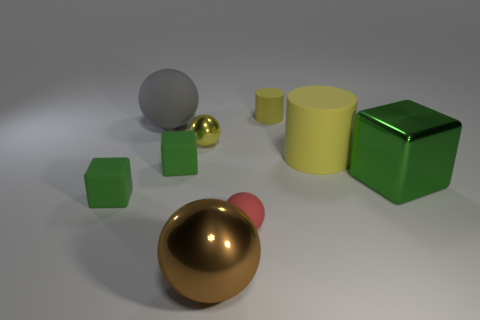What color is the tiny cylinder that is made of the same material as the large cylinder?
Your answer should be very brief. Yellow. There is a large rubber object that is to the left of the large brown shiny ball; does it have the same shape as the large matte thing right of the big brown ball?
Provide a succinct answer. No. How many shiny things are either cyan blocks or small cubes?
Your answer should be very brief. 0. What is the material of the tiny sphere that is the same color as the large cylinder?
Your response must be concise. Metal. What is the yellow cylinder in front of the tiny yellow metallic ball made of?
Your response must be concise. Rubber. Do the yellow cylinder in front of the gray matte sphere and the large green thing have the same material?
Ensure brevity in your answer.  No. What number of objects are small purple rubber things or yellow cylinders that are behind the big yellow rubber cylinder?
Your answer should be compact. 1. There is a red matte thing that is the same shape as the brown shiny object; what is its size?
Your answer should be compact. Small. There is a large cylinder; are there any big blocks right of it?
Offer a terse response. Yes. There is a tiny cube that is to the right of the large gray matte thing; does it have the same color as the block right of the small yellow metallic ball?
Your answer should be very brief. Yes. 